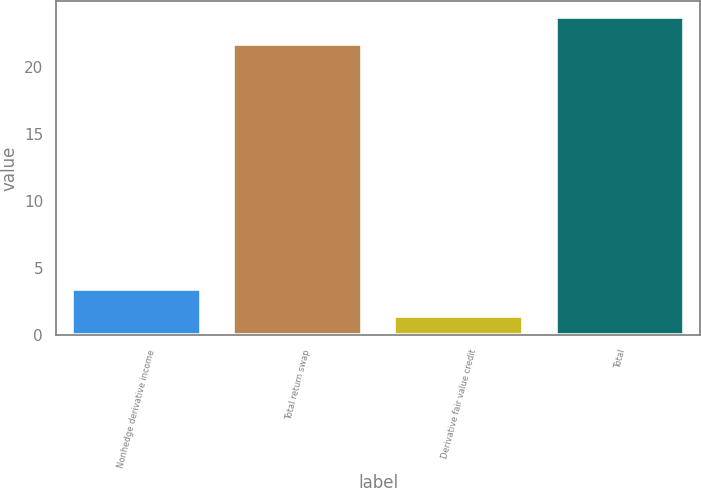Convert chart to OTSL. <chart><loc_0><loc_0><loc_500><loc_500><bar_chart><fcel>Nonhedge derivative income<fcel>Total return swap<fcel>Derivative fair value credit<fcel>Total<nl><fcel>3.44<fcel>21.7<fcel>1.4<fcel>23.74<nl></chart> 